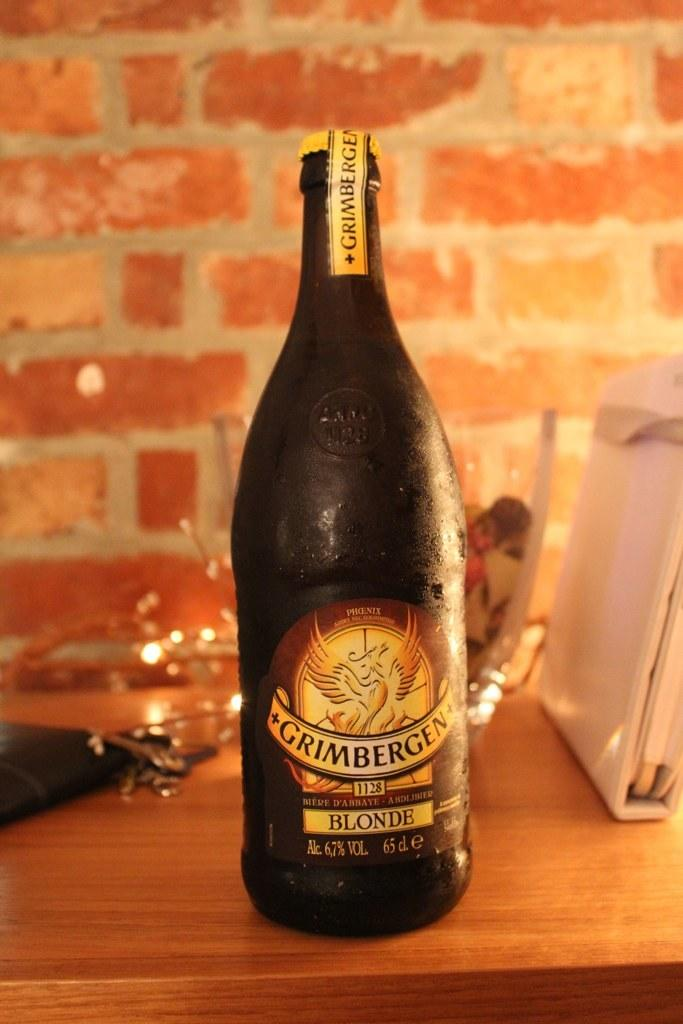What is on the table in the image? There is a bottle and glasses on the table. Are there any other objects on the table besides the bottle and glasses? Yes, there are other objects on the table. What can be seen in the background of the image? There is a wall in the background of the image. How does the magic seat levitate in the image? There is no magic seat present in the image. 